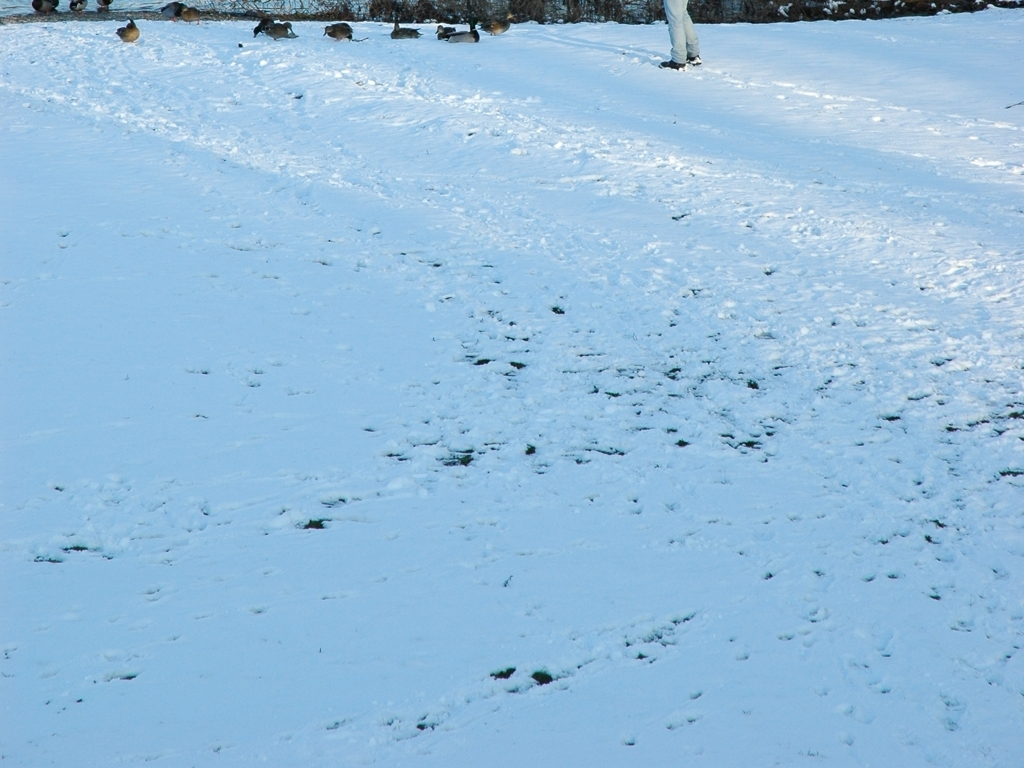How does the presence of the snow affect the local wildlife and plants? Snow can have a considerable impact on local wildlife and plants. Some animals hibernate or migrate to avoid the harsh conditions, while others have adapted to find food and shelter amid the snow. Plants may enter a period of dormancy, with only hardy species able to survive the freezing temperatures. 